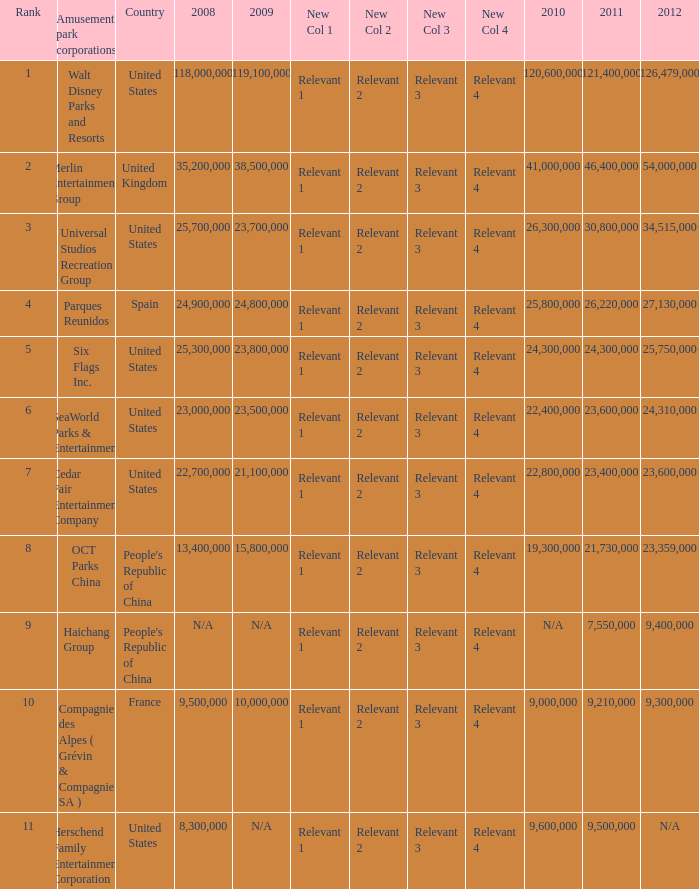In the United States the 2011 attendance at this amusement park corporation was larger than 30,800,000 but lists what as its 2008 attendance? 118000000.0. 